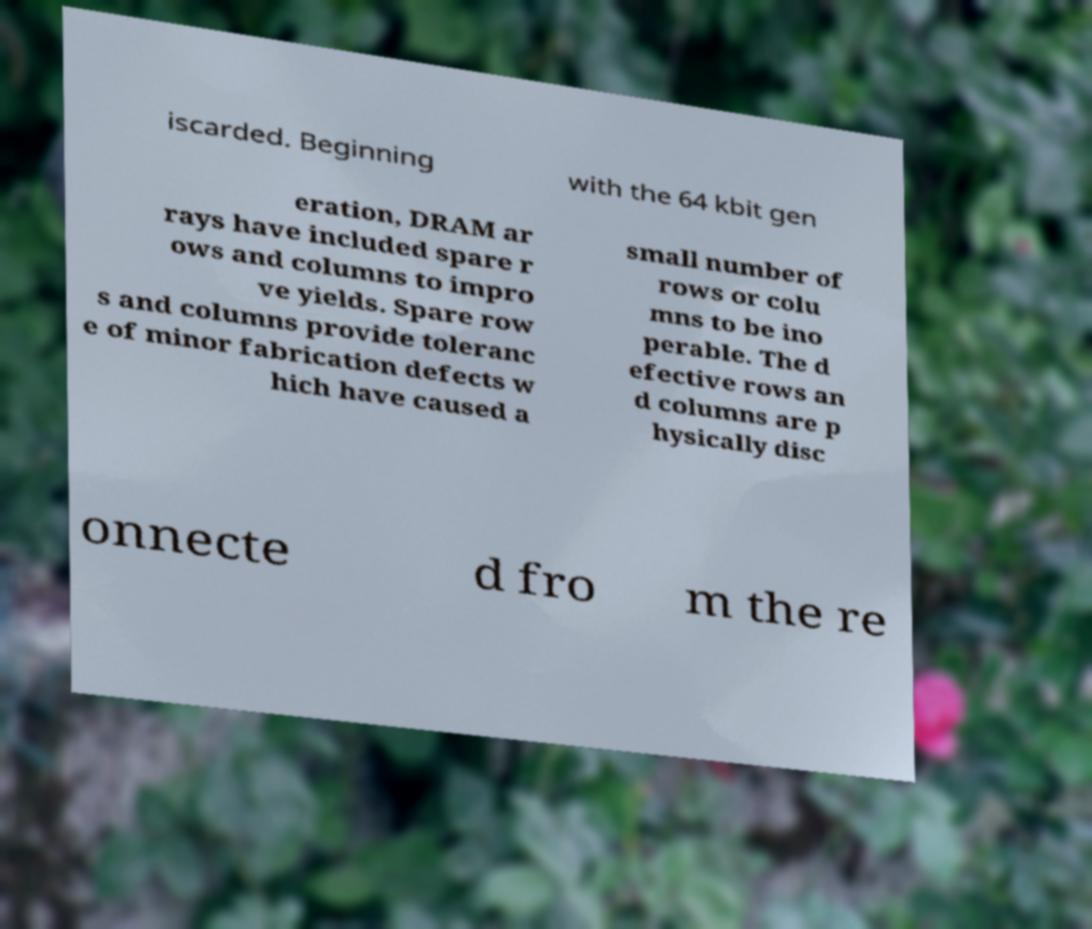What messages or text are displayed in this image? I need them in a readable, typed format. iscarded. Beginning with the 64 kbit gen eration, DRAM ar rays have included spare r ows and columns to impro ve yields. Spare row s and columns provide toleranc e of minor fabrication defects w hich have caused a small number of rows or colu mns to be ino perable. The d efective rows an d columns are p hysically disc onnecte d fro m the re 